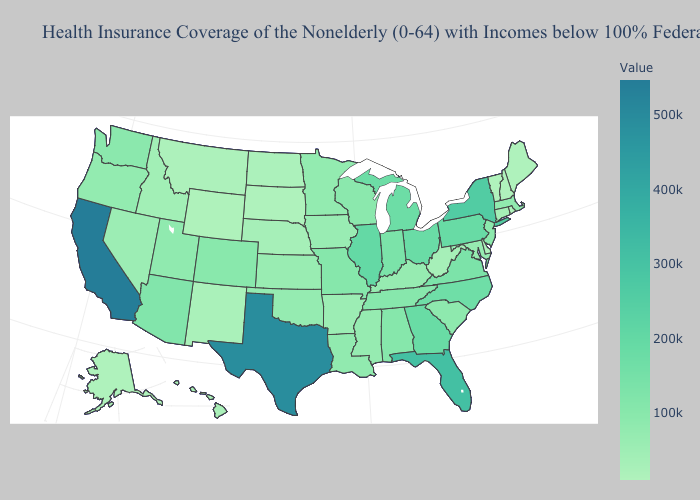Which states have the lowest value in the Northeast?
Answer briefly. Vermont. Does Massachusetts have the highest value in the Northeast?
Quick response, please. No. Which states have the lowest value in the MidWest?
Answer briefly. South Dakota. Is the legend a continuous bar?
Keep it brief. Yes. Does Michigan have the lowest value in the MidWest?
Concise answer only. No. Which states have the highest value in the USA?
Quick response, please. California. 